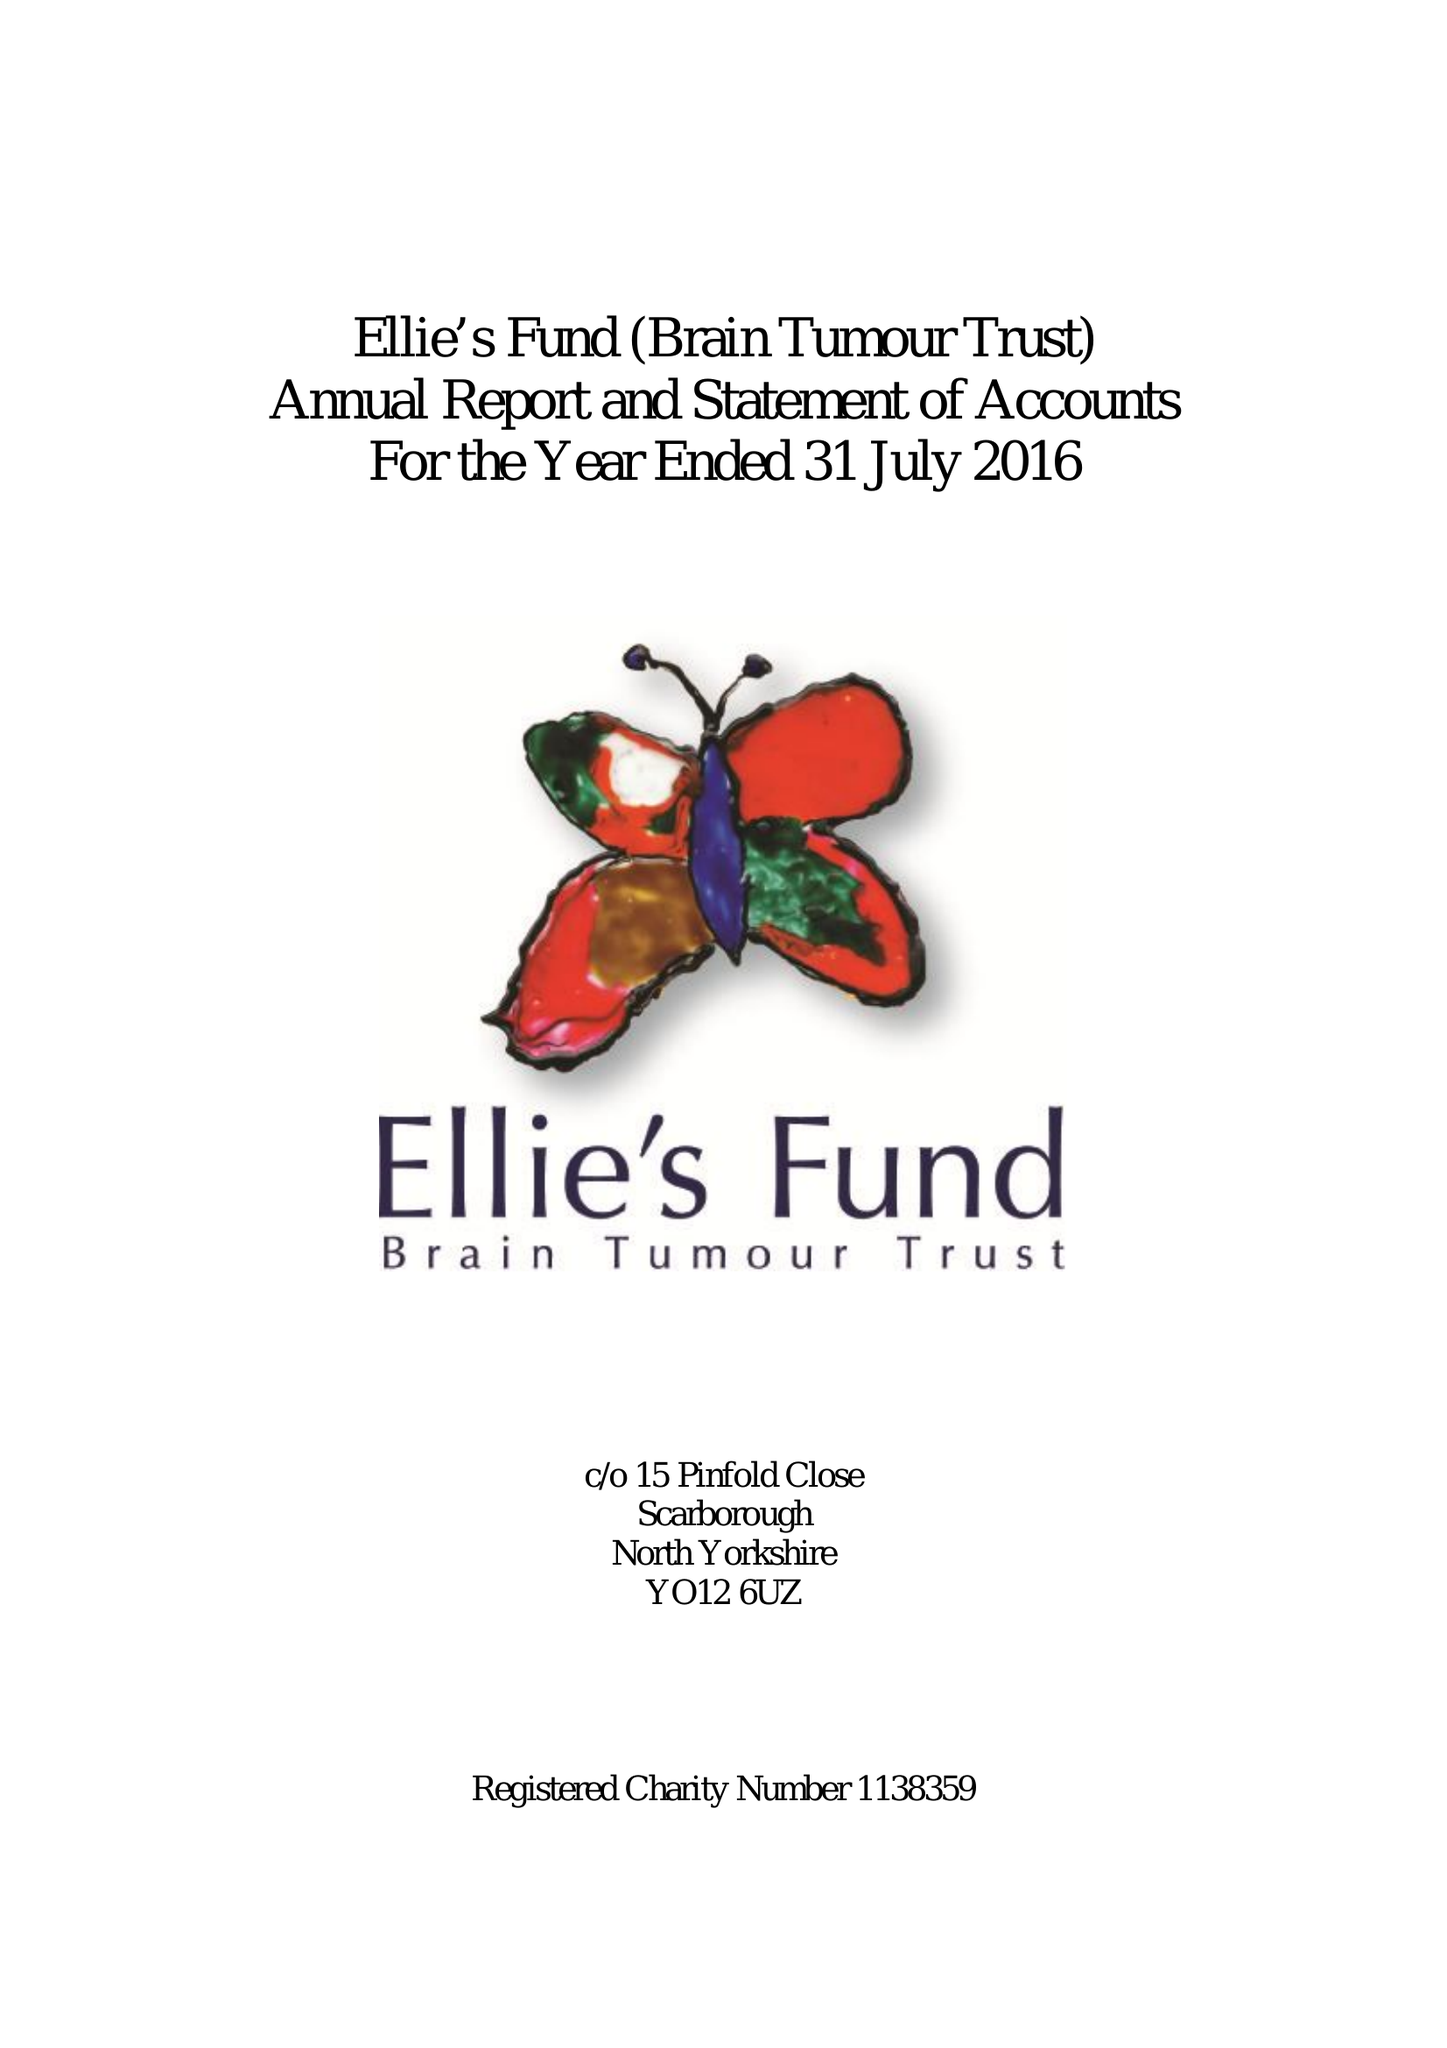What is the value for the charity_number?
Answer the question using a single word or phrase. 1138359 